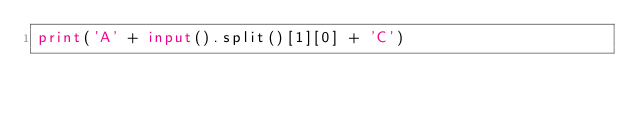Convert code to text. <code><loc_0><loc_0><loc_500><loc_500><_Python_>print('A' + input().split()[1][0] + 'C')</code> 